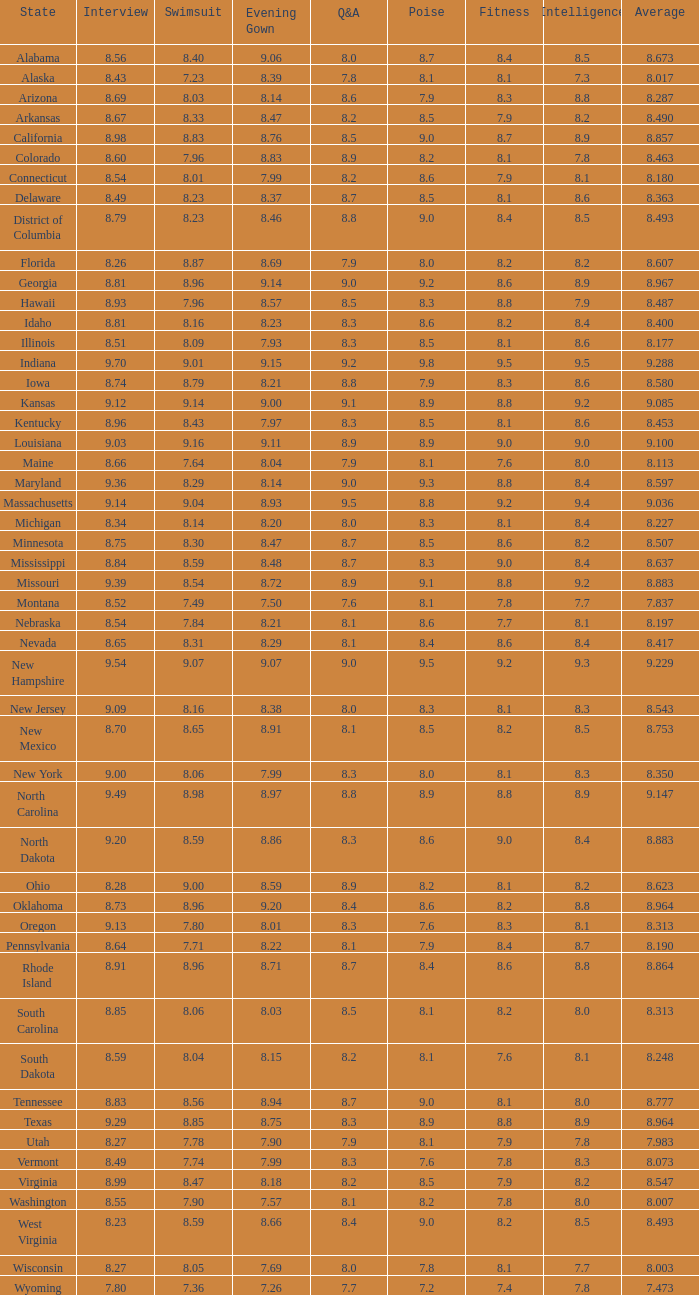Tell me the sum of interview for evening gown more than 8.37 and average of 8.363 None. 